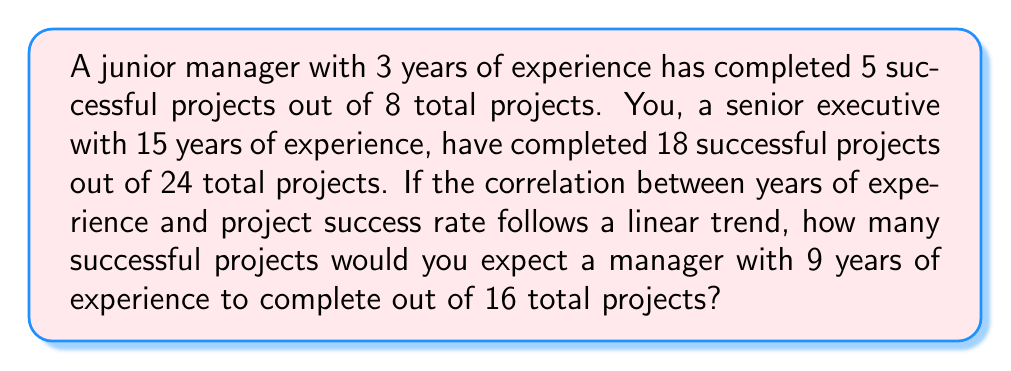Show me your answer to this math problem. Let's approach this step-by-step:

1) First, calculate the success rates for both the junior manager and yourself:

   Junior manager: $\frac{5}{8} = 0.625$ or 62.5%
   You: $\frac{18}{24} = 0.75$ or 75%

2) Now, we need to find the linear relationship between years of experience and success rate:

   Let $y$ be the success rate and $x$ be the years of experience.
   We have two points: $(3, 0.625)$ and $(15, 0.75)$

3) The slope of this line is:

   $m = \frac{0.75 - 0.625}{15 - 3} = \frac{0.125}{12} = 0.0104167$

4) Using the point-slope form of a line:

   $y - y_1 = m(x - x_1)$
   $y - 0.625 = 0.0104167(x - 3)$

5) Simplify to get the equation of the line:

   $y = 0.0104167x + 0.59375$

6) For 9 years of experience, plug in $x = 9$:

   $y = 0.0104167(9) + 0.59375 = 0.6875$

7) So, for 16 total projects, the expected number of successful projects is:

   $16 * 0.6875 = 11$
Answer: 11 successful projects 